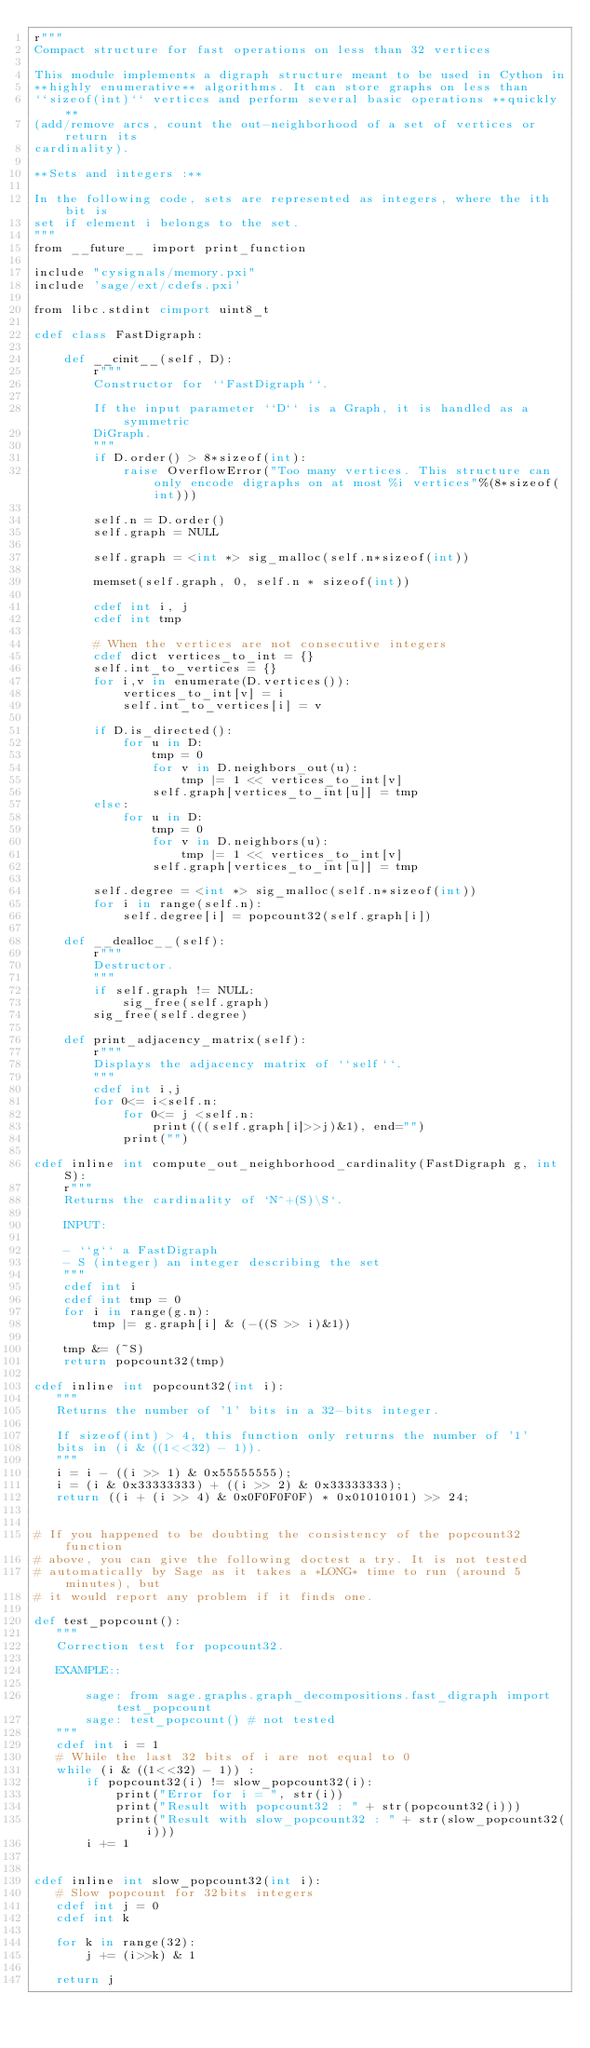Convert code to text. <code><loc_0><loc_0><loc_500><loc_500><_Cython_>r"""
Compact structure for fast operations on less than 32 vertices

This module implements a digraph structure meant to be used in Cython in
**highly enumerative** algorithms. It can store graphs on less than
``sizeof(int)`` vertices and perform several basic operations **quickly**
(add/remove arcs, count the out-neighborhood of a set of vertices or return its
cardinality).

**Sets and integers :**

In the following code, sets are represented as integers, where the ith bit is
set if element i belongs to the set.
"""
from __future__ import print_function

include "cysignals/memory.pxi"
include 'sage/ext/cdefs.pxi'

from libc.stdint cimport uint8_t

cdef class FastDigraph:

    def __cinit__(self, D):
        r"""
        Constructor for ``FastDigraph``.

        If the input parameter ``D`` is a Graph, it is handled as a symmetric
        DiGraph.
        """
        if D.order() > 8*sizeof(int):
            raise OverflowError("Too many vertices. This structure can only encode digraphs on at most %i vertices"%(8*sizeof(int)))

        self.n = D.order()
        self.graph = NULL

        self.graph = <int *> sig_malloc(self.n*sizeof(int))

        memset(self.graph, 0, self.n * sizeof(int))

        cdef int i, j
        cdef int tmp

        # When the vertices are not consecutive integers
        cdef dict vertices_to_int = {}
        self.int_to_vertices = {}
        for i,v in enumerate(D.vertices()):
            vertices_to_int[v] = i
            self.int_to_vertices[i] = v

        if D.is_directed():
            for u in D:
                tmp = 0
                for v in D.neighbors_out(u):
                    tmp |= 1 << vertices_to_int[v]
                self.graph[vertices_to_int[u]] = tmp
        else:
            for u in D:
                tmp = 0
                for v in D.neighbors(u):
                    tmp |= 1 << vertices_to_int[v]
                self.graph[vertices_to_int[u]] = tmp

        self.degree = <int *> sig_malloc(self.n*sizeof(int))
        for i in range(self.n):
            self.degree[i] = popcount32(self.graph[i])

    def __dealloc__(self):
        r"""
        Destructor.
        """
        if self.graph != NULL:
            sig_free(self.graph)
        sig_free(self.degree)

    def print_adjacency_matrix(self):
        r"""
        Displays the adjacency matrix of ``self``.
        """
        cdef int i,j
        for 0<= i<self.n:
            for 0<= j <self.n:
                print(((self.graph[i]>>j)&1), end="")
            print("")

cdef inline int compute_out_neighborhood_cardinality(FastDigraph g, int S):
    r"""
    Returns the cardinality of `N^+(S)\S`.

    INPUT:

    - ``g`` a FastDigraph
    - S (integer) an integer describing the set
    """
    cdef int i
    cdef int tmp = 0
    for i in range(g.n):
        tmp |= g.graph[i] & (-((S >> i)&1))

    tmp &= (~S)
    return popcount32(tmp)

cdef inline int popcount32(int i):
   """
   Returns the number of '1' bits in a 32-bits integer.

   If sizeof(int) > 4, this function only returns the number of '1'
   bits in (i & ((1<<32) - 1)).
   """
   i = i - ((i >> 1) & 0x55555555);
   i = (i & 0x33333333) + ((i >> 2) & 0x33333333);
   return ((i + (i >> 4) & 0x0F0F0F0F) * 0x01010101) >> 24;


# If you happened to be doubting the consistency of the popcount32 function
# above, you can give the following doctest a try. It is not tested
# automatically by Sage as it takes a *LONG* time to run (around 5 minutes), but
# it would report any problem if it finds one.

def test_popcount():
   """
   Correction test for popcount32.

   EXAMPLE::

       sage: from sage.graphs.graph_decompositions.fast_digraph import test_popcount
       sage: test_popcount() # not tested
   """
   cdef int i = 1
   # While the last 32 bits of i are not equal to 0
   while (i & ((1<<32) - 1)) :
       if popcount32(i) != slow_popcount32(i):
           print("Error for i = ", str(i))
           print("Result with popcount32 : " + str(popcount32(i)))
           print("Result with slow_popcount32 : " + str(slow_popcount32(i)))
       i += 1


cdef inline int slow_popcount32(int i):
   # Slow popcount for 32bits integers
   cdef int j = 0
   cdef int k

   for k in range(32):
       j += (i>>k) & 1

   return j
</code> 